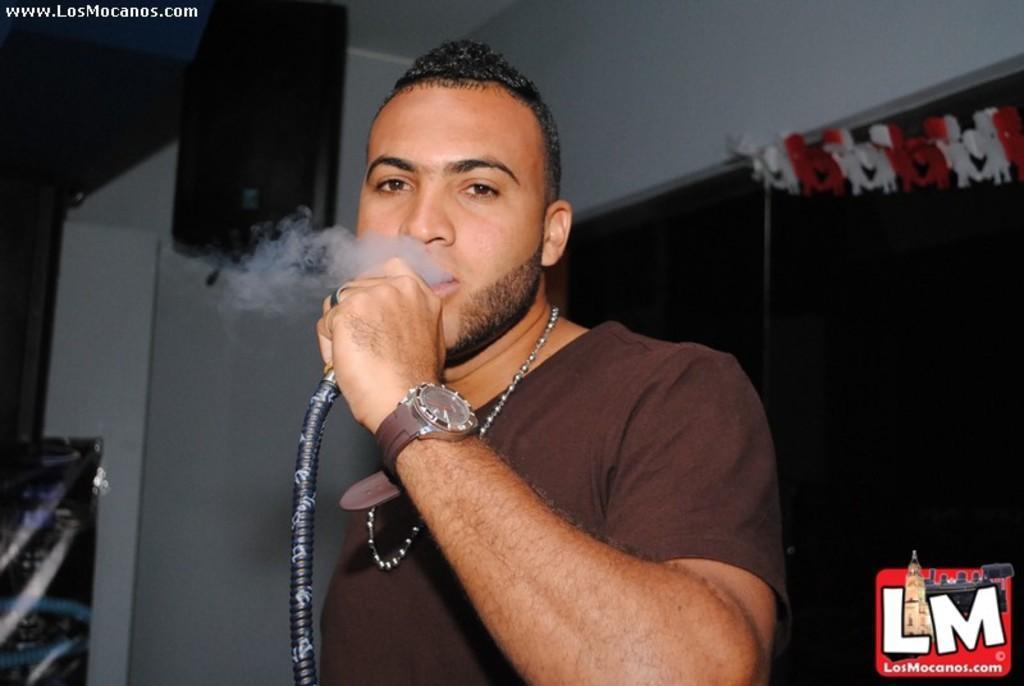Can you describe this image briefly? This image is taken indoors. In the background there is a wall and there is an object. At the top of the image there is a roof. In the middle of the image a man is standing and he is smoking. He is holding a pipe in his hand. On the right side of the image there are a few paper flags and there is a watermark in the image. 